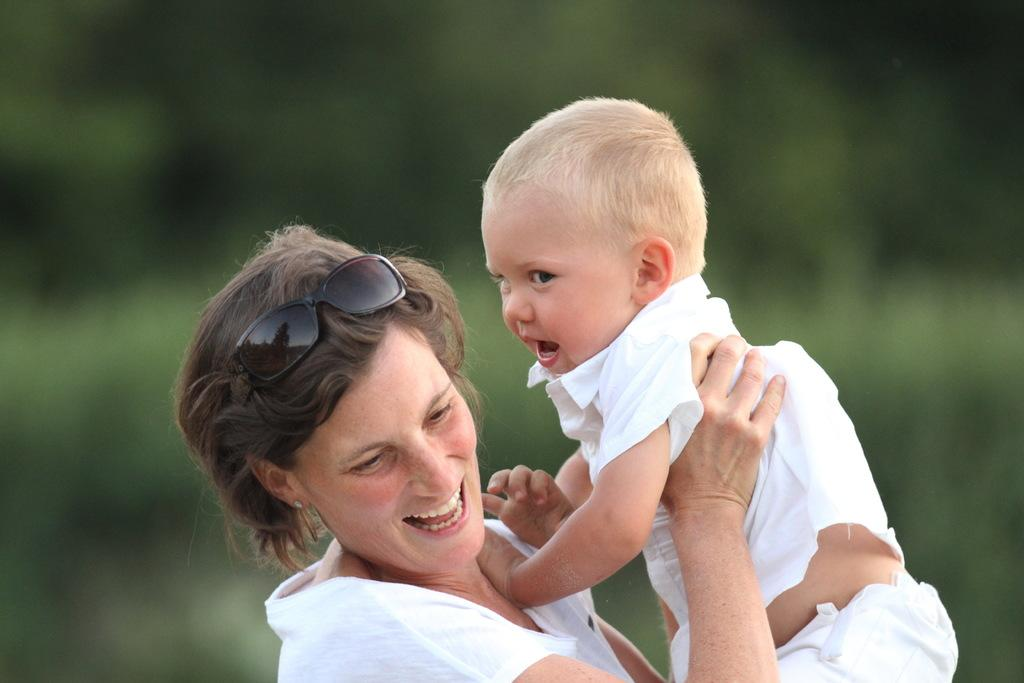Who is the main subject in the image? There is a woman in the image. What is the woman doing in the image? The woman is holding a baby. How are the woman and the baby feeling in the image? Both the woman and the baby are smiling. What is the baby wearing in the image? The baby is wearing a white t-shirt. What type of brush is the baby using to paint in the image? There is no brush or painting activity present in the image. How much was the payment for the baby's t-shirt in the image? There is no payment or transaction related to the baby's t-shirt in the image. 